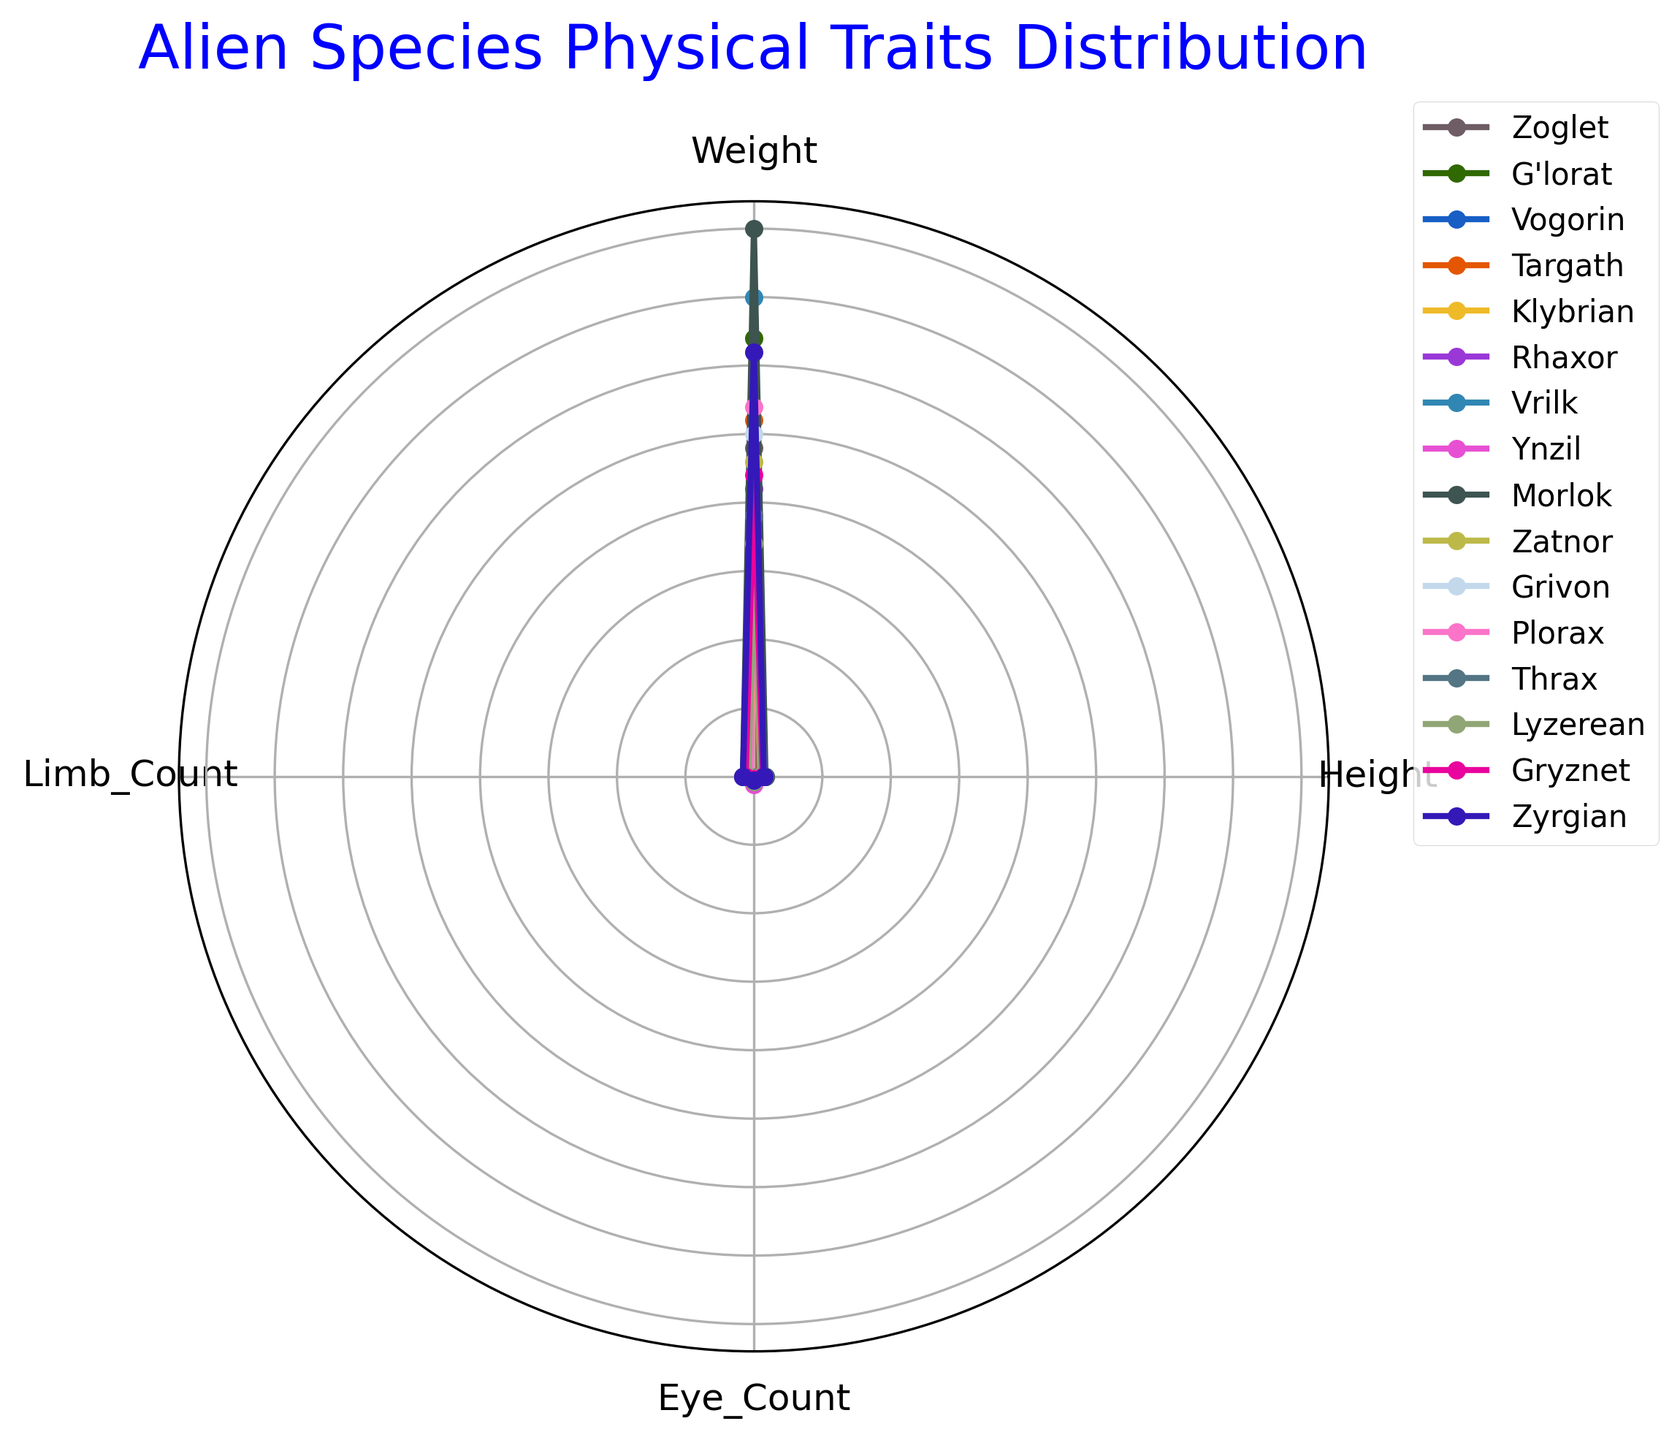Which alien species has the highest limb count? To find the answer, look at the values plotted for the "Limb_Count" category in the radar chart. The species with the farthest point from the center in this category has the highest limb count.
Answer: Thrax Which alien species have exactly 4 limbs? Look at the plots in the "Limb_Count" category. The alien species with their plot points exactly matching the value of 4 in this category should be identified.
Answer: G'lorat, Targath, Vrilk, Ynzil, Grivon, Lyzerean Compare Zoglet and G'lorat: which one is taller and by how much? In the "Height" category, compare the distance of Zoglet and G'lorat's plot points from the center. Zoglet's point is plotted at 7.2 and G'lorat's at 5.5. Subtract G'lorat's height from Zoglet's.
Answer: Zoglet by 1.7 units Which alien species has the lowest number of eyes? Look at the "Eye_Count" category and find the species with the closest plot point to the center in this category.
Answer: Thrax How do the heights of Vogorin and Morlok compare? Locate the points for Vogorin and Morlok in the "Height" category. Vogorin is at 8.1 and Morlok is at 8.5. By comparing these two values, Morlok is taller than Vogorin.
Answer: Morlok is taller by 0.4 units What's the average weight of the three heaviest alien species? First, determine the three species with the plot points farthest from the center in the "Weight" category. These are Morlok (400), Vrilk (350), and Zyrgian (310). Add these weights and divide by 3 to find the average.
Answer: 353.33 units Compare the skin texture types in visual complexity: which texture type appears the most varied among the species? Look at the legend to check the number of species having similar skin textures and observe how spread out they are across the chart.
Answer: There are multiple textures, though Scaly and Smooth might be more visually varied as they are represented by many species placed in different areas What is the total weight of the species with the lowest limb count? Identify the species with the lowest "Limb_Count". Both Klybrian and Plorax have the lowest counts of 2 limbs. Summing their weights: Klybrian (150) + Plorax (270) = 420 units.
Answer: 420 units 